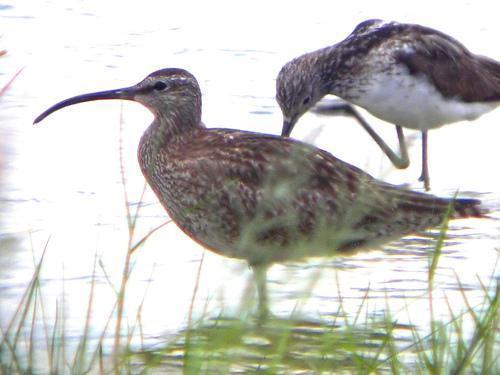How many birds are here?
Give a very brief answer. 2. 